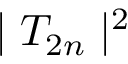Convert formula to latex. <formula><loc_0><loc_0><loc_500><loc_500>| T _ { 2 n } | ^ { 2 }</formula> 